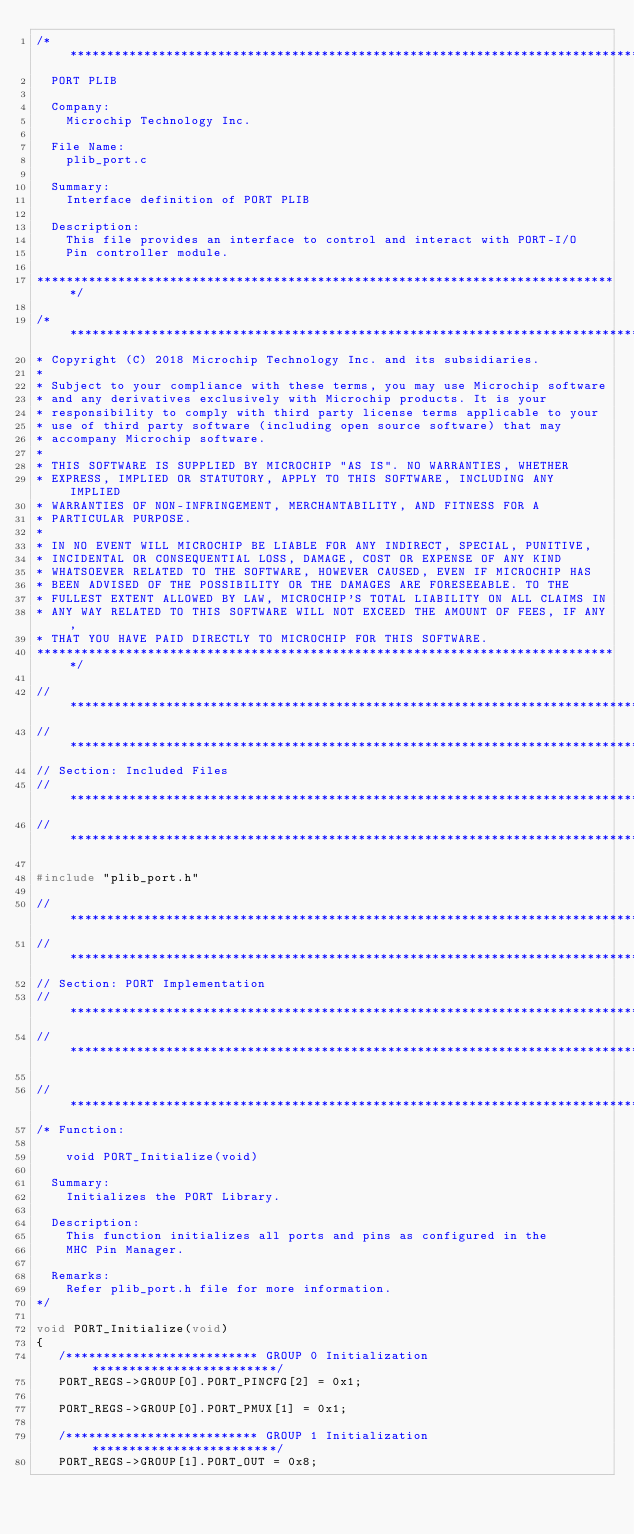Convert code to text. <code><loc_0><loc_0><loc_500><loc_500><_C_>/*******************************************************************************
  PORT PLIB

  Company:
    Microchip Technology Inc.

  File Name:
    plib_port.c

  Summary:
    Interface definition of PORT PLIB

  Description:
    This file provides an interface to control and interact with PORT-I/O
    Pin controller module.

*******************************************************************************/

/*******************************************************************************
* Copyright (C) 2018 Microchip Technology Inc. and its subsidiaries.
*
* Subject to your compliance with these terms, you may use Microchip software
* and any derivatives exclusively with Microchip products. It is your
* responsibility to comply with third party license terms applicable to your
* use of third party software (including open source software) that may
* accompany Microchip software.
*
* THIS SOFTWARE IS SUPPLIED BY MICROCHIP "AS IS". NO WARRANTIES, WHETHER
* EXPRESS, IMPLIED OR STATUTORY, APPLY TO THIS SOFTWARE, INCLUDING ANY IMPLIED
* WARRANTIES OF NON-INFRINGEMENT, MERCHANTABILITY, AND FITNESS FOR A
* PARTICULAR PURPOSE.
*
* IN NO EVENT WILL MICROCHIP BE LIABLE FOR ANY INDIRECT, SPECIAL, PUNITIVE,
* INCIDENTAL OR CONSEQUENTIAL LOSS, DAMAGE, COST OR EXPENSE OF ANY KIND
* WHATSOEVER RELATED TO THE SOFTWARE, HOWEVER CAUSED, EVEN IF MICROCHIP HAS
* BEEN ADVISED OF THE POSSIBILITY OR THE DAMAGES ARE FORESEEABLE. TO THE
* FULLEST EXTENT ALLOWED BY LAW, MICROCHIP'S TOTAL LIABILITY ON ALL CLAIMS IN
* ANY WAY RELATED TO THIS SOFTWARE WILL NOT EXCEED THE AMOUNT OF FEES, IF ANY,
* THAT YOU HAVE PAID DIRECTLY TO MICROCHIP FOR THIS SOFTWARE.
*******************************************************************************/

// *****************************************************************************
// *****************************************************************************
// Section: Included Files
// *****************************************************************************
// *****************************************************************************

#include "plib_port.h"

// *****************************************************************************
// *****************************************************************************
// Section: PORT Implementation
// *****************************************************************************
// *****************************************************************************

// *****************************************************************************
/* Function:

    void PORT_Initialize(void)

  Summary:
    Initializes the PORT Library.

  Description:
    This function initializes all ports and pins as configured in the
    MHC Pin Manager.

  Remarks:
    Refer plib_port.h file for more information.
*/

void PORT_Initialize(void)
{
   /************************** GROUP 0 Initialization *************************/
   PORT_REGS->GROUP[0].PORT_PINCFG[2] = 0x1;

   PORT_REGS->GROUP[0].PORT_PMUX[1] = 0x1;
                
   /************************** GROUP 1 Initialization *************************/
   PORT_REGS->GROUP[1].PORT_OUT = 0x8;</code> 